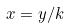<formula> <loc_0><loc_0><loc_500><loc_500>x = y / k</formula> 